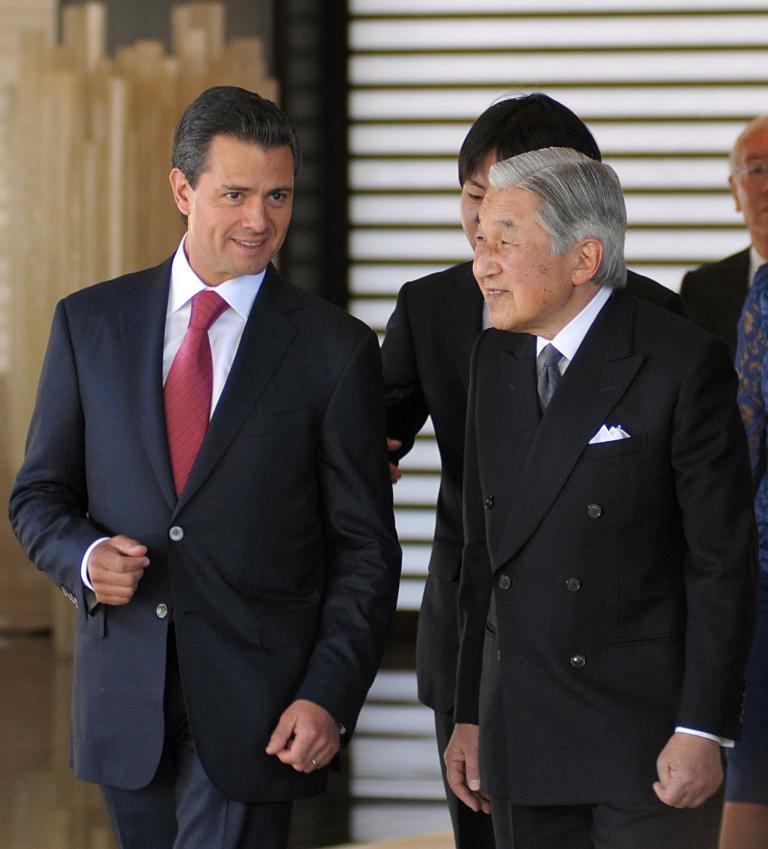In one or two sentences, can you explain what this image depicts? In the picture there are many people present, behind them there is a wall. 